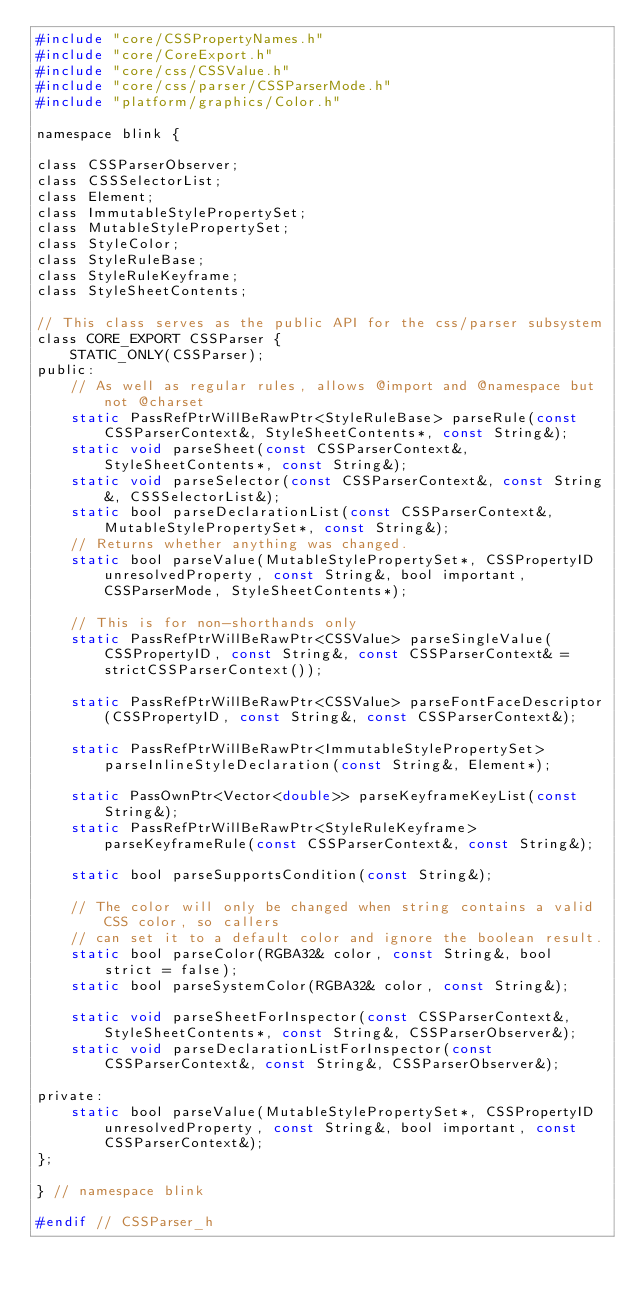Convert code to text. <code><loc_0><loc_0><loc_500><loc_500><_C_>#include "core/CSSPropertyNames.h"
#include "core/CoreExport.h"
#include "core/css/CSSValue.h"
#include "core/css/parser/CSSParserMode.h"
#include "platform/graphics/Color.h"

namespace blink {

class CSSParserObserver;
class CSSSelectorList;
class Element;
class ImmutableStylePropertySet;
class MutableStylePropertySet;
class StyleColor;
class StyleRuleBase;
class StyleRuleKeyframe;
class StyleSheetContents;

// This class serves as the public API for the css/parser subsystem
class CORE_EXPORT CSSParser {
    STATIC_ONLY(CSSParser);
public:
    // As well as regular rules, allows @import and @namespace but not @charset
    static PassRefPtrWillBeRawPtr<StyleRuleBase> parseRule(const CSSParserContext&, StyleSheetContents*, const String&);
    static void parseSheet(const CSSParserContext&, StyleSheetContents*, const String&);
    static void parseSelector(const CSSParserContext&, const String&, CSSSelectorList&);
    static bool parseDeclarationList(const CSSParserContext&, MutableStylePropertySet*, const String&);
    // Returns whether anything was changed.
    static bool parseValue(MutableStylePropertySet*, CSSPropertyID unresolvedProperty, const String&, bool important, CSSParserMode, StyleSheetContents*);

    // This is for non-shorthands only
    static PassRefPtrWillBeRawPtr<CSSValue> parseSingleValue(CSSPropertyID, const String&, const CSSParserContext& = strictCSSParserContext());

    static PassRefPtrWillBeRawPtr<CSSValue> parseFontFaceDescriptor(CSSPropertyID, const String&, const CSSParserContext&);

    static PassRefPtrWillBeRawPtr<ImmutableStylePropertySet> parseInlineStyleDeclaration(const String&, Element*);

    static PassOwnPtr<Vector<double>> parseKeyframeKeyList(const String&);
    static PassRefPtrWillBeRawPtr<StyleRuleKeyframe> parseKeyframeRule(const CSSParserContext&, const String&);

    static bool parseSupportsCondition(const String&);

    // The color will only be changed when string contains a valid CSS color, so callers
    // can set it to a default color and ignore the boolean result.
    static bool parseColor(RGBA32& color, const String&, bool strict = false);
    static bool parseSystemColor(RGBA32& color, const String&);

    static void parseSheetForInspector(const CSSParserContext&, StyleSheetContents*, const String&, CSSParserObserver&);
    static void parseDeclarationListForInspector(const CSSParserContext&, const String&, CSSParserObserver&);

private:
    static bool parseValue(MutableStylePropertySet*, CSSPropertyID unresolvedProperty, const String&, bool important, const CSSParserContext&);
};

} // namespace blink

#endif // CSSParser_h
</code> 